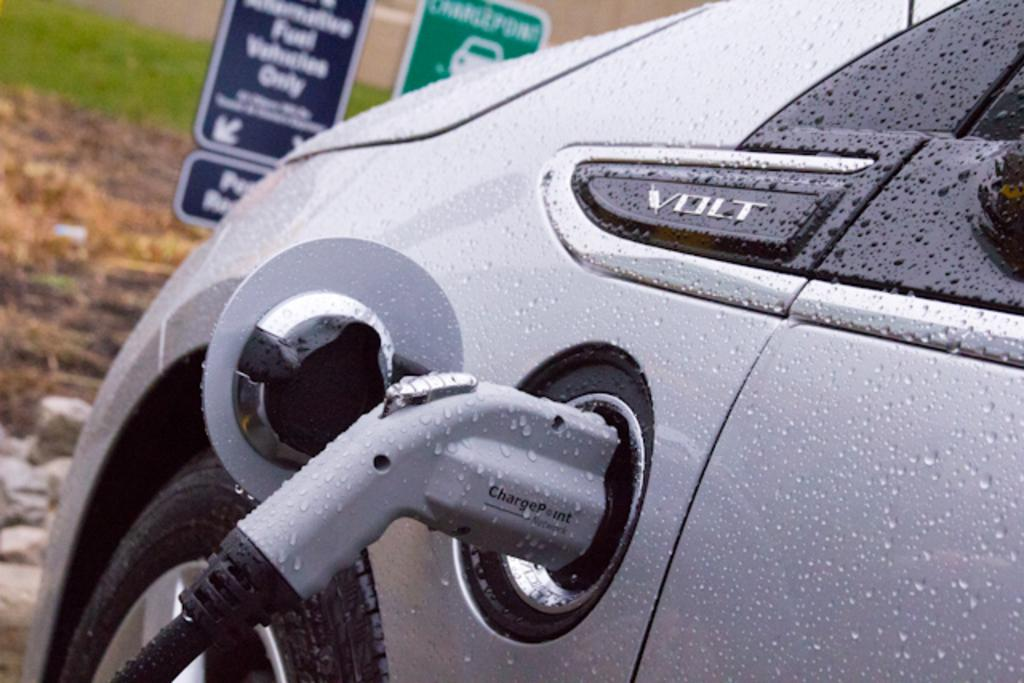What is the main subject of the image? The main subject of the image is a car. Is there anything attached to the car? Yes, there is an object attached to the car. What can be seen in the background of the image? There are boards in the background of the image. What is written on the boards? Something is written on the boards. How would you describe the background of the image? The background of the image is blurred. What type of pleasure can be seen enjoying a lunch in the image? There is no indication of pleasure or lunch in the image; it features a car with an attached object and blurred boards in the background. 